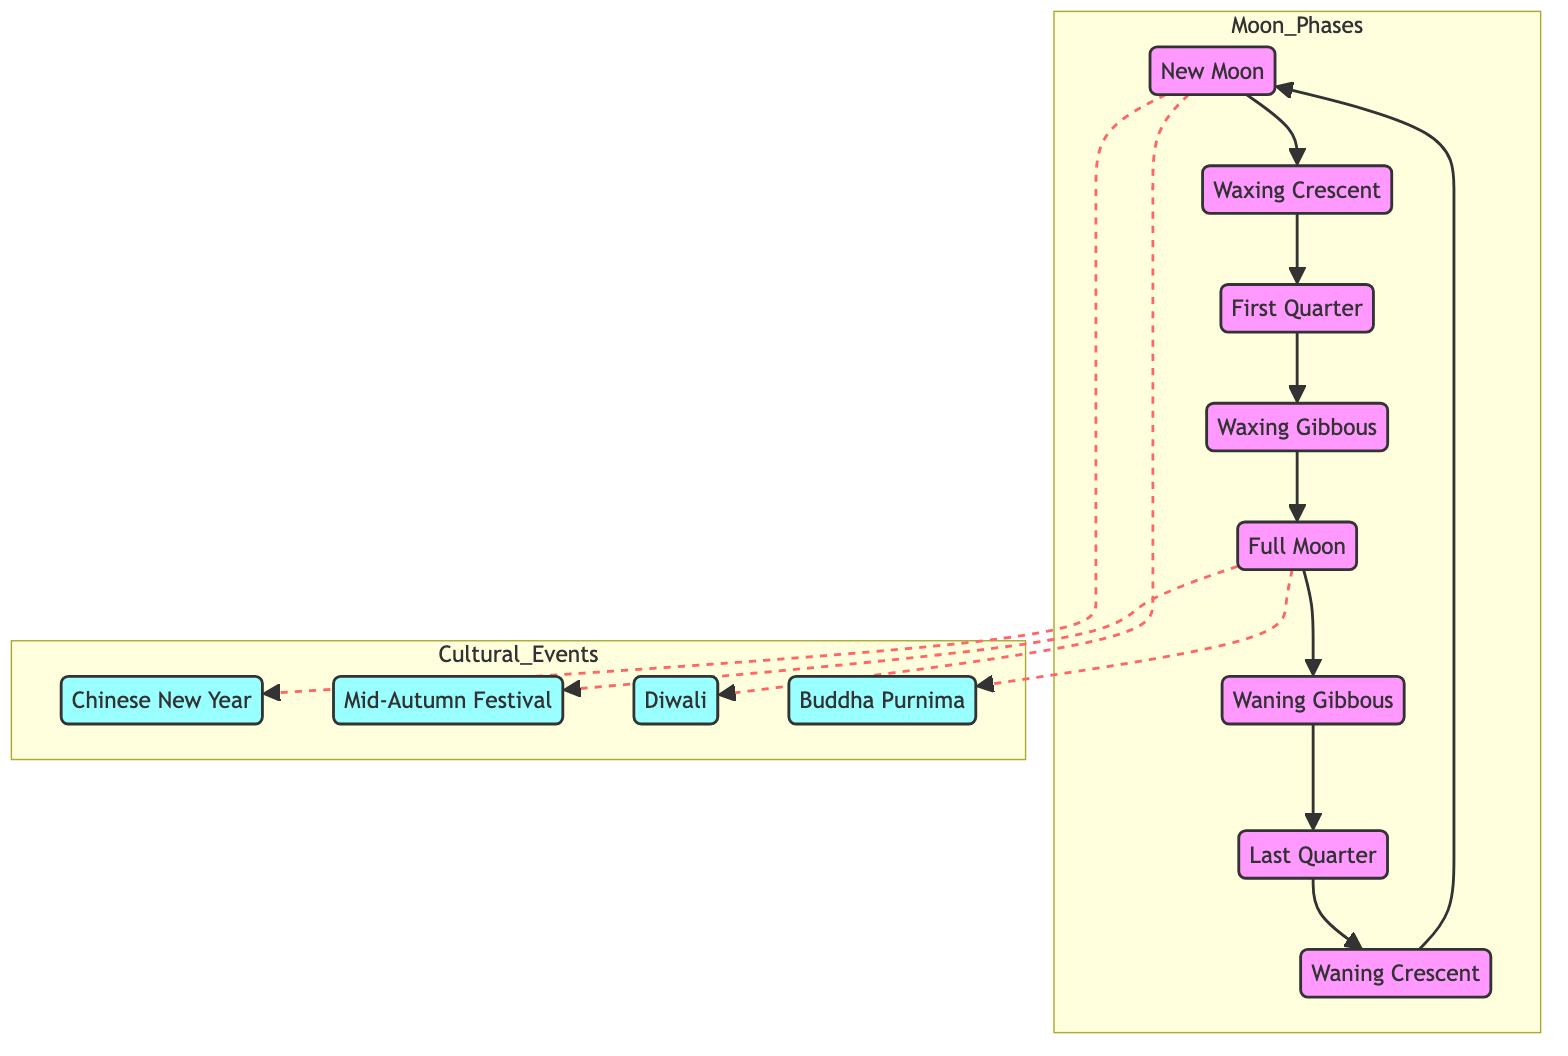What is the first phase of the Moon shown in the diagram? The diagram begins with the New Moon phase labeled as NM. This is the starting point of the transition towards the Full Moon.
Answer: New Moon How many total phases of the Moon are depicted? The diagram shows eight distinct phases of the Moon, from New Moon to Waning Crescent, creating a complete cycle.
Answer: Eight Which cultural event is connected to the Full Moon? The diagram links two cultural events to the Full Moon: the Mid-Autumn Festival and Buddha Purnima, both of which are notable celebrations observed during this phase.
Answer: Mid-Autumn Festival, Buddha Purnima What phase immediately follows the First Quarter phase? According to the diagram, the phase that follows First Quarter (FQ) is the Waxing Gibbous (WG), demonstrating the progression of the lunar cycle.
Answer: Waxing Gibbous Which phase has cultural events associated with it? Both the New Moon (NM) and Full Moon (FM) phases have cultural events associated, as indicated by the dashed lines connecting them to relevant events.
Answer: New Moon, Full Moon During which phase does the Lunar cycle return to its starting point? The cycle returns to the New Moon phase (NM) after completing all phases, as shown by the arrow looping back to NM.
Answer: New Moon What type of line connects cultural events to the Moon phases? The cultural events are connected to their respective Moon phases using dashed lines, which visually differentiate these associations from the solid lines depicting lunar phases.
Answer: Dashed lines Which fraction of the Moon's cycle is represented by the Waxing Gibbous? The Waxing Gibbous (WG) phase occurs after the First Quarter, indicating it occupies a critical position in the Moon's transitions before reaching Full Moon.
Answer: The fraction is not explicitly depicted in the diagram 